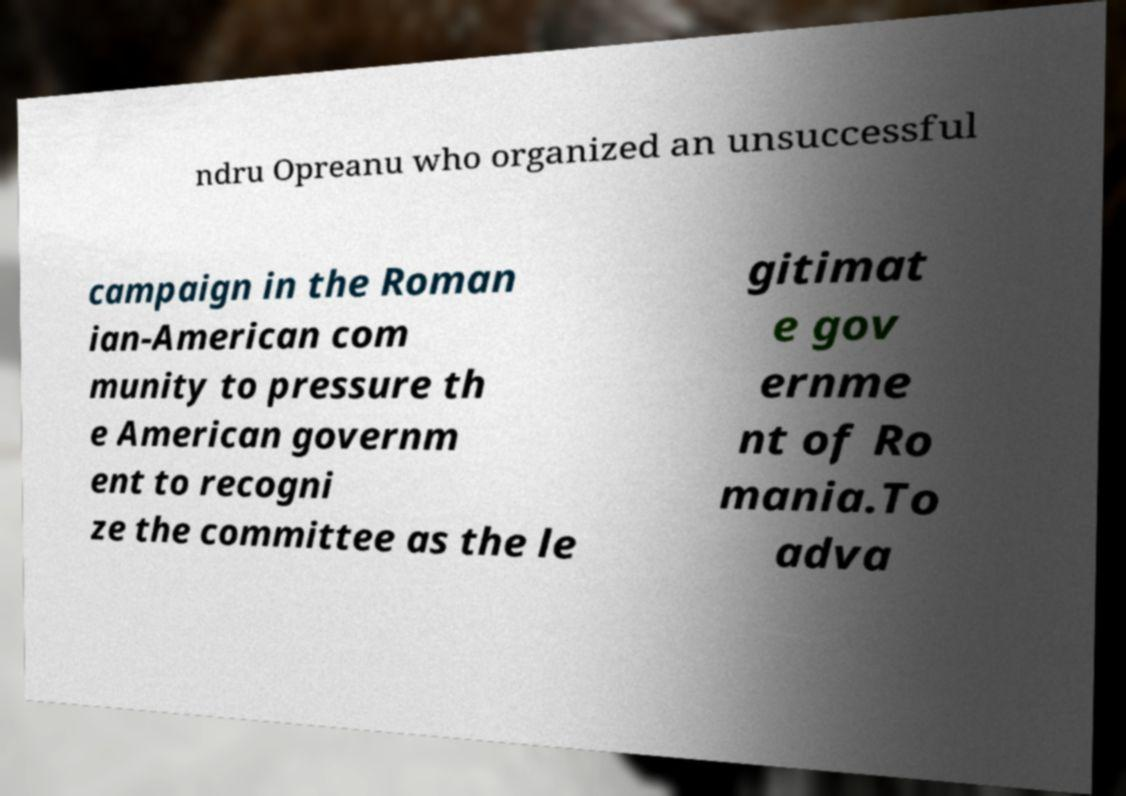Can you read and provide the text displayed in the image?This photo seems to have some interesting text. Can you extract and type it out for me? ndru Opreanu who organized an unsuccessful campaign in the Roman ian-American com munity to pressure th e American governm ent to recogni ze the committee as the le gitimat e gov ernme nt of Ro mania.To adva 